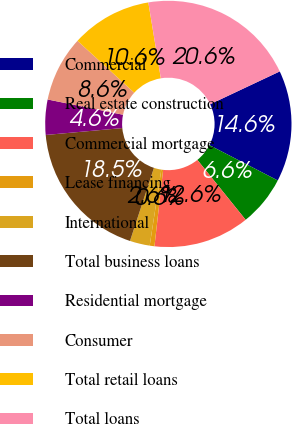Convert chart. <chart><loc_0><loc_0><loc_500><loc_500><pie_chart><fcel>Commercial<fcel>Real estate construction<fcel>Commercial mortgage<fcel>Lease financing<fcel>International<fcel>Total business loans<fcel>Residential mortgage<fcel>Consumer<fcel>Total retail loans<fcel>Total loans<nl><fcel>14.6%<fcel>6.61%<fcel>12.6%<fcel>0.62%<fcel>2.62%<fcel>18.53%<fcel>4.61%<fcel>8.61%<fcel>10.61%<fcel>20.59%<nl></chart> 